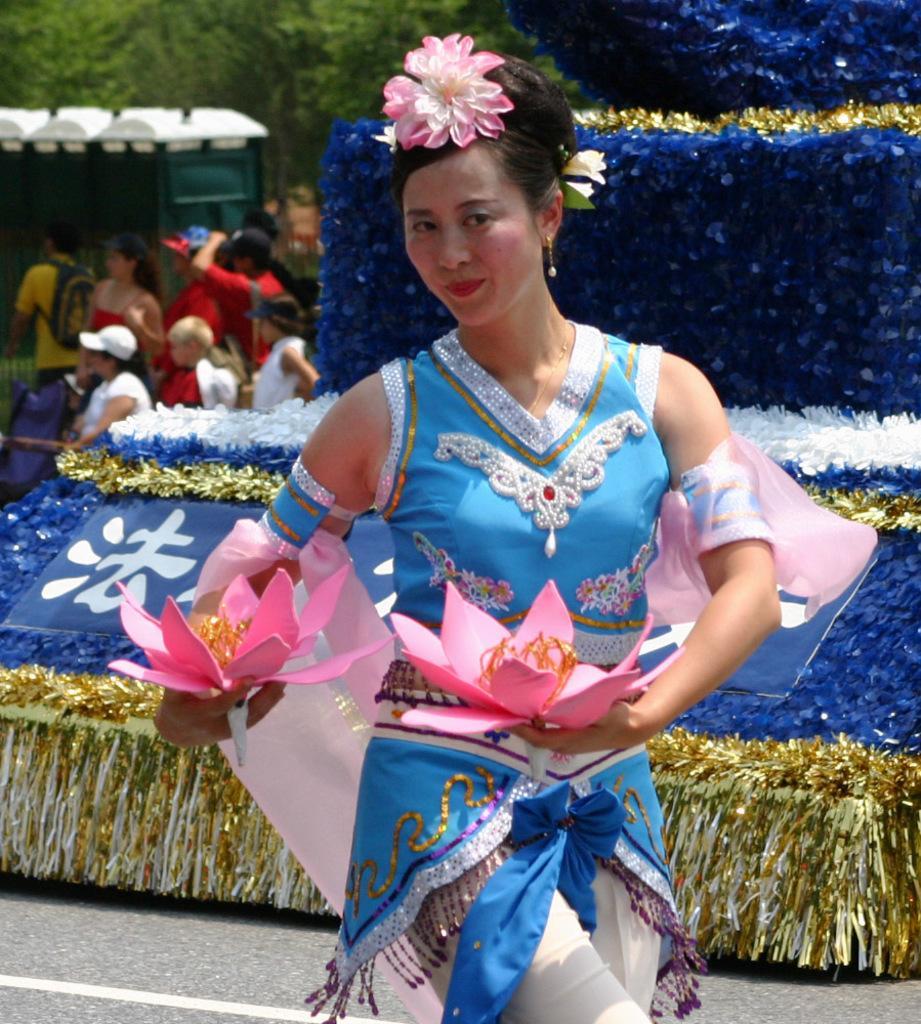Could you give a brief overview of what you see in this image? This image consists of a woman wearing blue dress and holding flowers. In the background, there are blue color clothes. And there are many people along with the trees. 